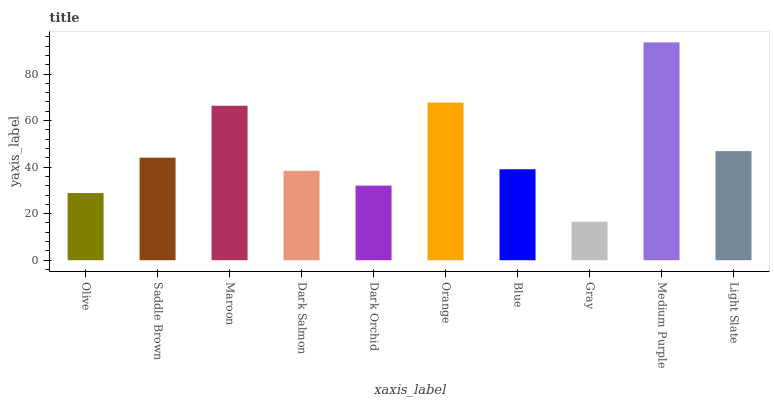Is Saddle Brown the minimum?
Answer yes or no. No. Is Saddle Brown the maximum?
Answer yes or no. No. Is Saddle Brown greater than Olive?
Answer yes or no. Yes. Is Olive less than Saddle Brown?
Answer yes or no. Yes. Is Olive greater than Saddle Brown?
Answer yes or no. No. Is Saddle Brown less than Olive?
Answer yes or no. No. Is Saddle Brown the high median?
Answer yes or no. Yes. Is Blue the low median?
Answer yes or no. Yes. Is Orange the high median?
Answer yes or no. No. Is Saddle Brown the low median?
Answer yes or no. No. 